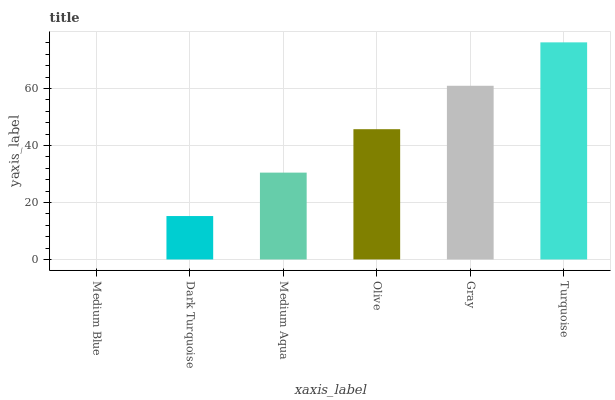Is Medium Blue the minimum?
Answer yes or no. Yes. Is Turquoise the maximum?
Answer yes or no. Yes. Is Dark Turquoise the minimum?
Answer yes or no. No. Is Dark Turquoise the maximum?
Answer yes or no. No. Is Dark Turquoise greater than Medium Blue?
Answer yes or no. Yes. Is Medium Blue less than Dark Turquoise?
Answer yes or no. Yes. Is Medium Blue greater than Dark Turquoise?
Answer yes or no. No. Is Dark Turquoise less than Medium Blue?
Answer yes or no. No. Is Olive the high median?
Answer yes or no. Yes. Is Medium Aqua the low median?
Answer yes or no. Yes. Is Medium Aqua the high median?
Answer yes or no. No. Is Medium Blue the low median?
Answer yes or no. No. 